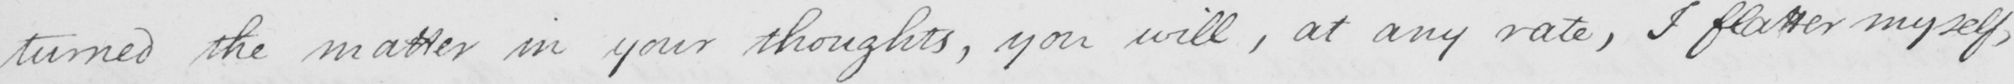What is written in this line of handwriting? turned the matter in your thoughts , you will , at any rate , I flatter myself , 